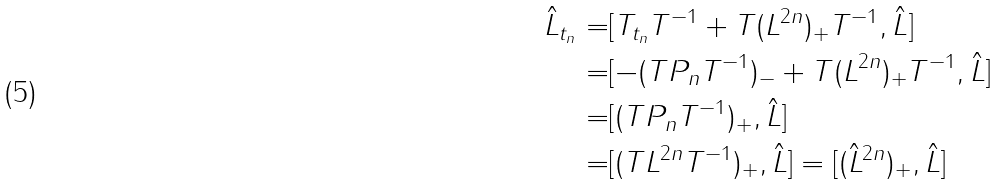<formula> <loc_0><loc_0><loc_500><loc_500>\hat { L } _ { t _ { n } } = & [ T _ { t _ { n } } T ^ { - 1 } + T ( L ^ { 2 n } ) _ { + } T ^ { - 1 } , \hat { L } ] \\ = & [ - ( T P _ { n } T ^ { - 1 } ) _ { - } + T ( L ^ { 2 n } ) _ { + } T ^ { - 1 } , \hat { L } ] \\ = & [ ( T P _ { n } T ^ { - 1 } ) _ { + } , \hat { L } ] \\ = & [ ( T L ^ { 2 n } T ^ { - 1 } ) _ { + } , \hat { L } ] = [ ( \hat { L } ^ { 2 n } ) _ { + } , \hat { L } ]</formula> 